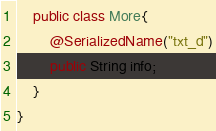Convert code to text. <code><loc_0><loc_0><loc_500><loc_500><_Java_>    public class More{
        @SerializedName("txt_d")
        public String info;
    }
}
</code> 